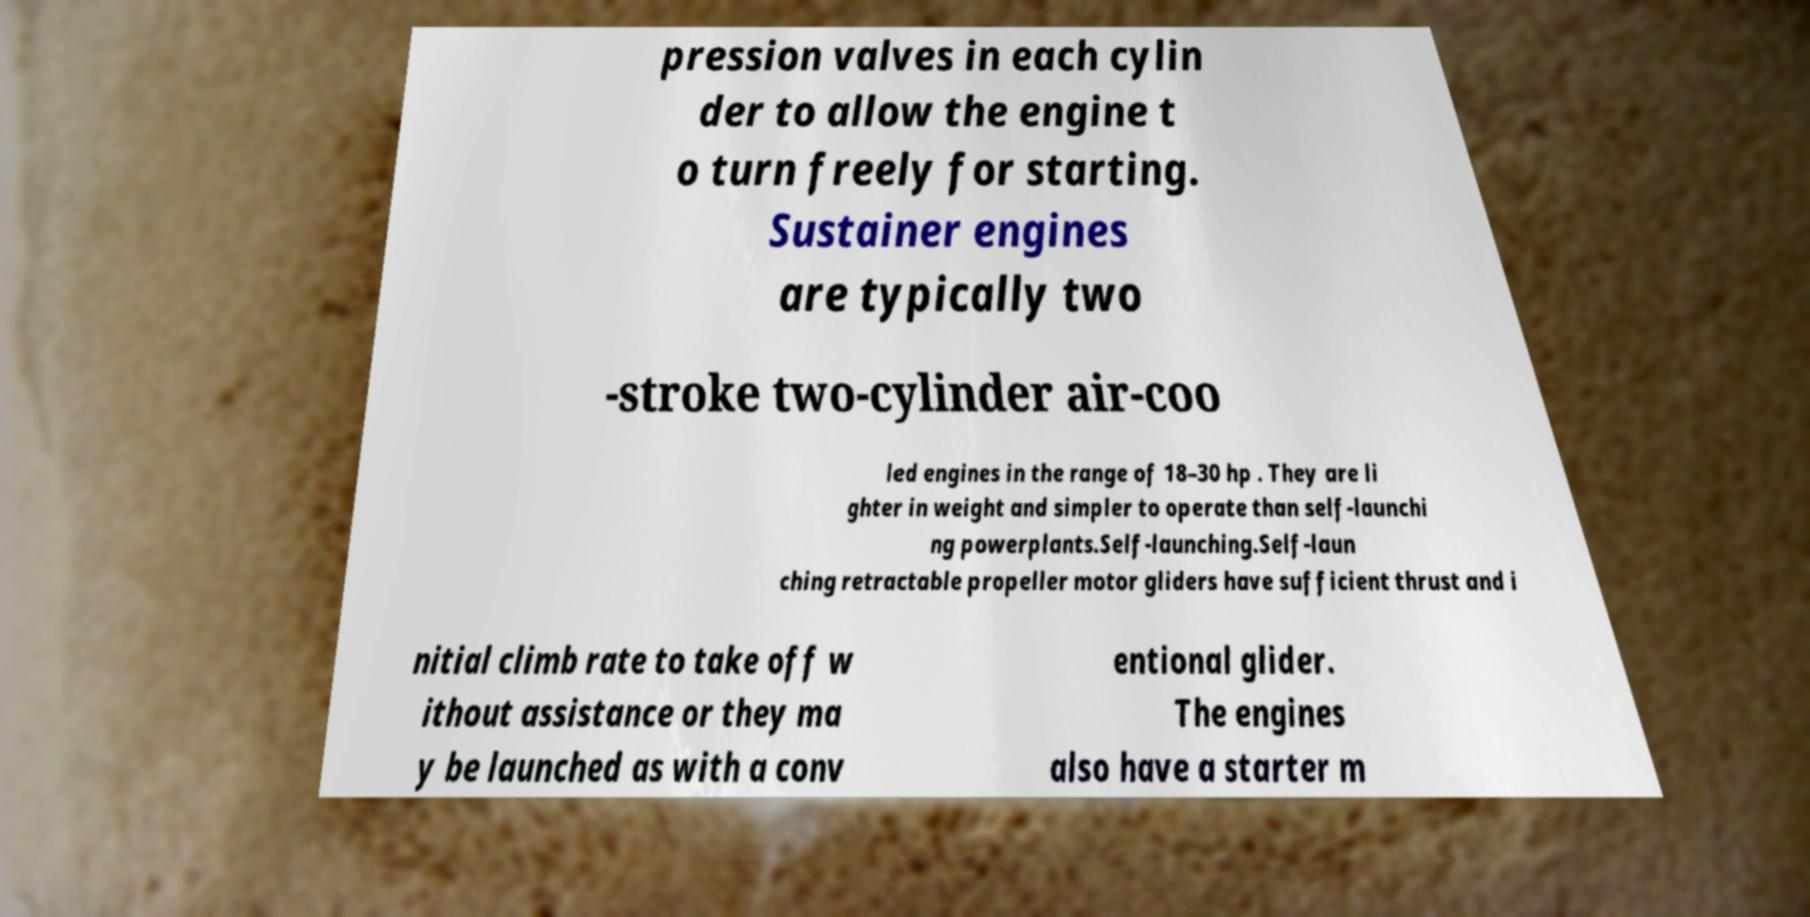Can you read and provide the text displayed in the image?This photo seems to have some interesting text. Can you extract and type it out for me? pression valves in each cylin der to allow the engine t o turn freely for starting. Sustainer engines are typically two -stroke two-cylinder air-coo led engines in the range of 18–30 hp . They are li ghter in weight and simpler to operate than self-launchi ng powerplants.Self-launching.Self-laun ching retractable propeller motor gliders have sufficient thrust and i nitial climb rate to take off w ithout assistance or they ma y be launched as with a conv entional glider. The engines also have a starter m 